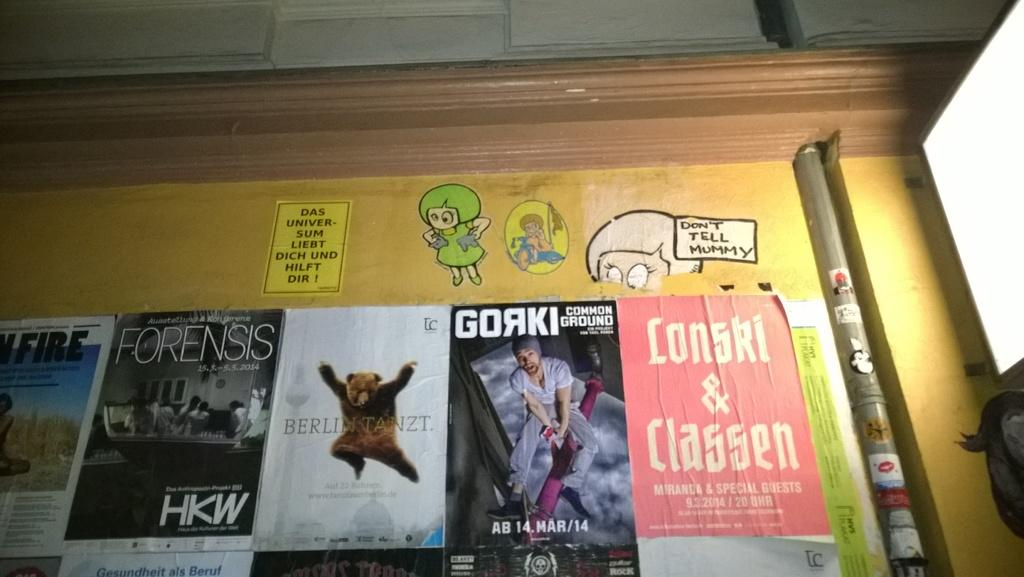Provide a one-sentence caption for the provided image. A collection of magazine covers are posted to a billboard along with a message that says don't tell mummy. 